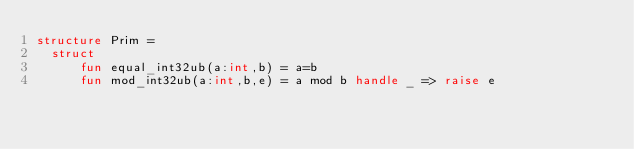Convert code to text. <code><loc_0><loc_0><loc_500><loc_500><_SML_>structure Prim =
  struct
      fun equal_int32ub(a:int,b) = a=b
      fun mod_int32ub(a:int,b,e) = a mod b handle _ => raise e</code> 